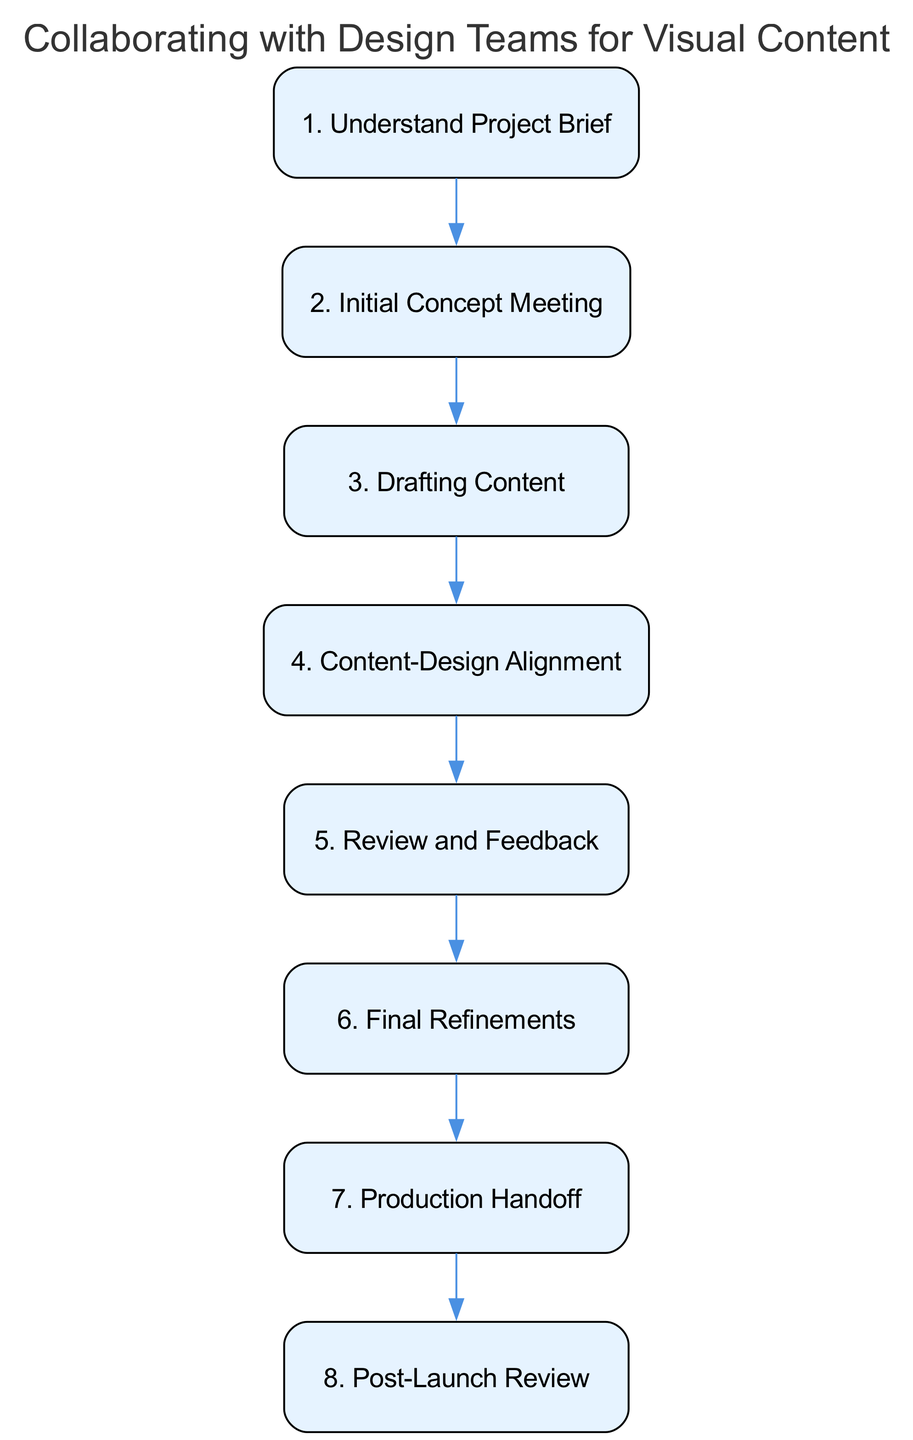What's the first step in the diagram? The first step in the diagram is labeled "1. Understand Project Brief", which indicates the initial action to be taken in the collaborative process.
Answer: Understand Project Brief How many steps are there in total? By counting the elements in the diagram, there are a total of 8 steps represented in the flow.
Answer: 8 What follows "Review and Feedback"? The step following "Review and Feedback" is "Final Refinements", indicating the next phase after gathering feedback.
Answer: Final Refinements Which step involves the production team? The step that involves the production team is "Production Handoff", where final assets are prepared and given to the production team for implementation.
Answer: Production Handoff What two steps are linked directly by an edge? The steps "Drafting Content" and "Content-Design Alignment" are directly linked by an edge, indicating a sequential relationship in the workflow.
Answer: Drafting Content and Content-Design Alignment What is the last step in the process? The last step in the process is "Post-Launch Review", which signifies the final evaluation phase after the visual content has been implemented.
Answer: Post-Launch Review Which steps focus on feedback and adjustments? The steps focused on feedback and adjustments are "Review and Feedback" and "Final Refinements", showing the iterative nature of collaboration.
Answer: Review and Feedback, Final Refinements How does "Initial Concept Meeting" relate to the following step? "Initial Concept Meeting" leads to "Drafting Content", indicating that brainstorming ideas directly influences the subsequent content writing process.
Answer: Leads to Drafting Content What is the purpose of the "Content-Design Alignment" step? The purpose of the "Content-Design Alignment" step is to ensure that the copy and visuals work together cohesively, conveying a unified message.
Answer: To ensure cohesive messaging 